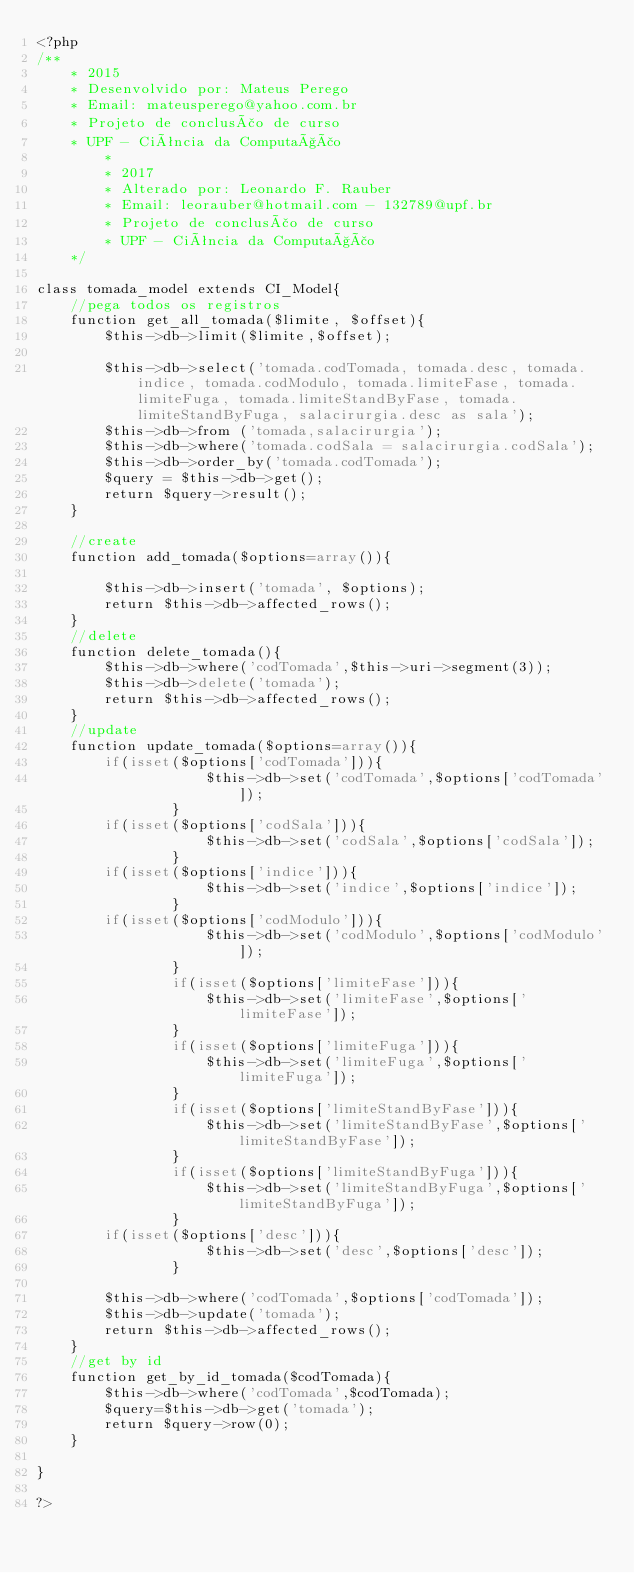<code> <loc_0><loc_0><loc_500><loc_500><_PHP_><?php
/**
	* 2015
	* Desenvolvido por: Mateus Perego
	* Email: mateusperego@yahoo.com.br
	* Projeto de conclusão de curso
	* UPF - Ciência da Computação
        *  
        * 2017
        * Alterado por: Leonardo F. Rauber
        * Email: leorauber@hotmail.com - 132789@upf.br
        * Projeto de conclusão de curso
        * UPF - Ciência da Computação
	*/	

class tomada_model extends CI_Model{
	//pega todos os registros
	function get_all_tomada($limite, $offset){
		$this->db->limit($limite,$offset);

		$this->db->select('tomada.codTomada, tomada.desc, tomada.indice, tomada.codModulo, tomada.limiteFase, tomada.limiteFuga, tomada.limiteStandByFase, tomada.limiteStandByFuga, salacirurgia.desc as sala');
		$this->db->from ('tomada,salacirurgia');
		$this->db->where('tomada.codSala = salacirurgia.codSala');
		$this->db->order_by('tomada.codTomada');
		$query = $this->db->get();
		return $query->result();
	}
	
	//create 
	function add_tomada($options=array()){

		$this->db->insert('tomada', $options);
		return $this->db->affected_rows();
	}
	//delete 
	function delete_tomada(){
		$this->db->where('codTomada',$this->uri->segment(3));
		$this->db->delete('tomada');
		return $this->db->affected_rows();
	}
	//update 
	function update_tomada($options=array()){
		if(isset($options['codTomada'])){
                    $this->db->set('codTomada',$options['codTomada']);
                }
		if(isset($options['codSala'])){
                    $this->db->set('codSala',$options['codSala']);
                }
		if(isset($options['indice'])){
                    $this->db->set('indice',$options['indice']);
                }
		if(isset($options['codModulo'])){
                    $this->db->set('codModulo',$options['codModulo']);
                }
                if(isset($options['limiteFase'])){
                    $this->db->set('limiteFase',$options['limiteFase']);
                }
                if(isset($options['limiteFuga'])){
                    $this->db->set('limiteFuga',$options['limiteFuga']);
                }
                if(isset($options['limiteStandByFase'])){
                    $this->db->set('limiteStandByFase',$options['limiteStandByFase']);
                }
                if(isset($options['limiteStandByFuga'])){
                    $this->db->set('limiteStandByFuga',$options['limiteStandByFuga']);
                }
		if(isset($options['desc'])){
                    $this->db->set('desc',$options['desc']);
                }

		$this->db->where('codTomada',$options['codTomada']);
		$this->db->update('tomada');
		return $this->db->affected_rows();
	}
	//get by id
	function get_by_id_tomada($codTomada){
		$this->db->where('codTomada',$codTomada);
		$query=$this->db->get('tomada');
		return $query->row(0);
	}

} 

?></code> 